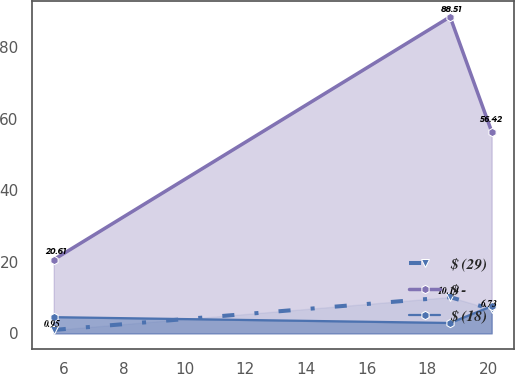Convert chart to OTSL. <chart><loc_0><loc_0><loc_500><loc_500><line_chart><ecel><fcel>$ (29)<fcel>$ -<fcel>$ (18)<nl><fcel>5.68<fcel>0.95<fcel>20.61<fcel>4.53<nl><fcel>18.75<fcel>10.14<fcel>88.51<fcel>2.9<nl><fcel>20.12<fcel>6.73<fcel>56.42<fcel>7.6<nl></chart> 